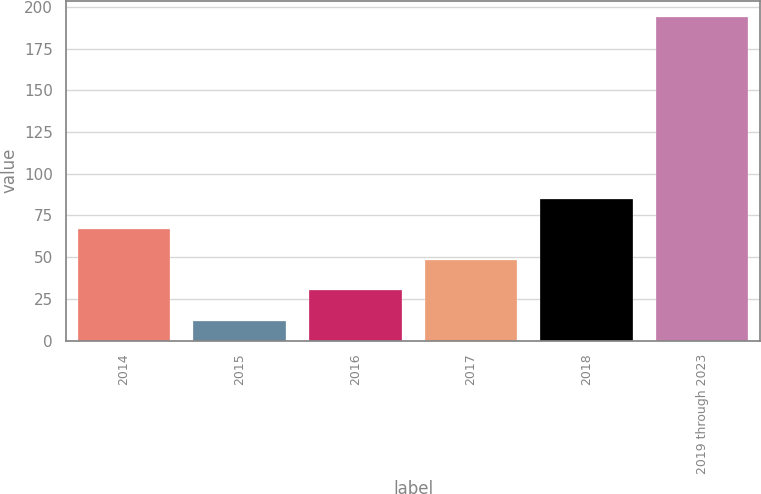Convert chart to OTSL. <chart><loc_0><loc_0><loc_500><loc_500><bar_chart><fcel>2014<fcel>2015<fcel>2016<fcel>2017<fcel>2018<fcel>2019 through 2023<nl><fcel>66.6<fcel>12<fcel>30.2<fcel>48.4<fcel>84.8<fcel>194<nl></chart> 